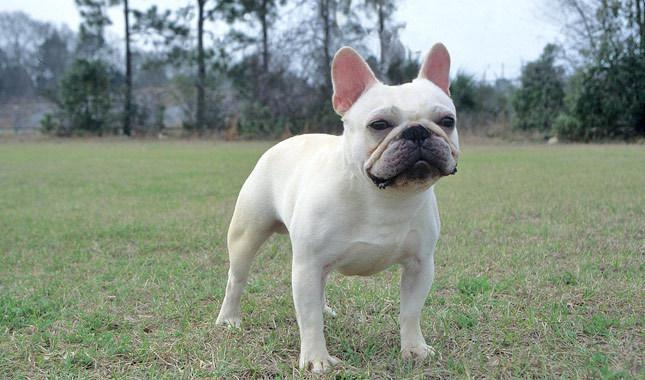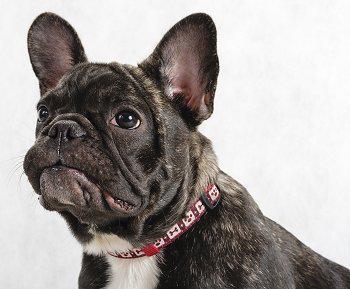The first image is the image on the left, the second image is the image on the right. For the images displayed, is the sentence "At least one dog is wearing a red collar." factually correct? Answer yes or no. Yes. The first image is the image on the left, the second image is the image on the right. For the images shown, is this caption "There is atleast one white, pied french bulldog." true? Answer yes or no. No. 